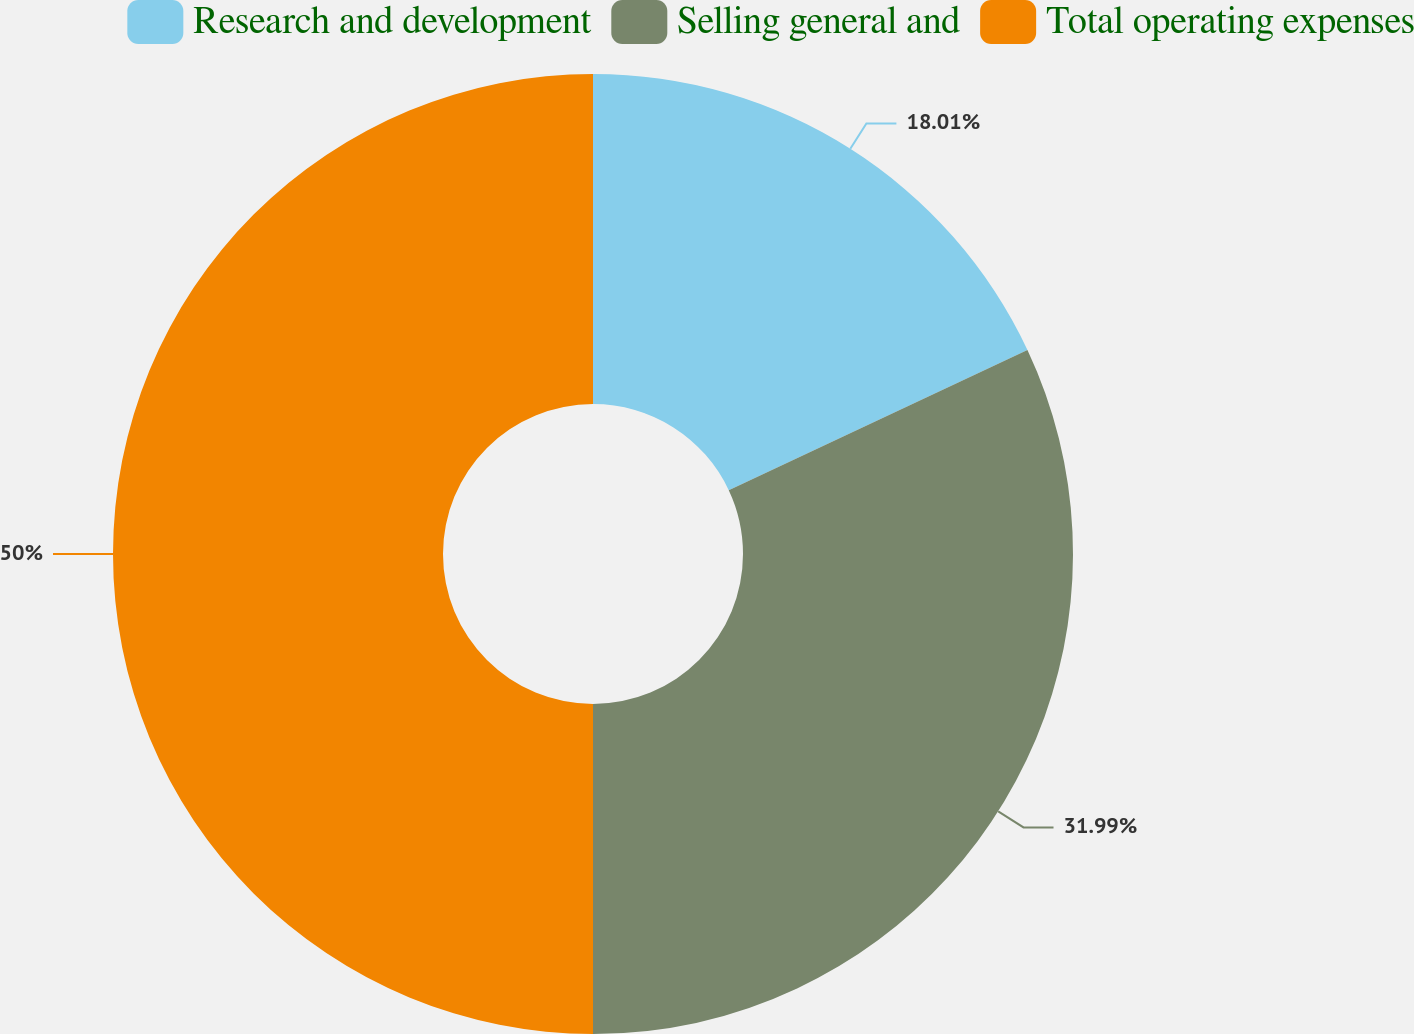Convert chart to OTSL. <chart><loc_0><loc_0><loc_500><loc_500><pie_chart><fcel>Research and development<fcel>Selling general and<fcel>Total operating expenses<nl><fcel>18.01%<fcel>31.99%<fcel>50.0%<nl></chart> 